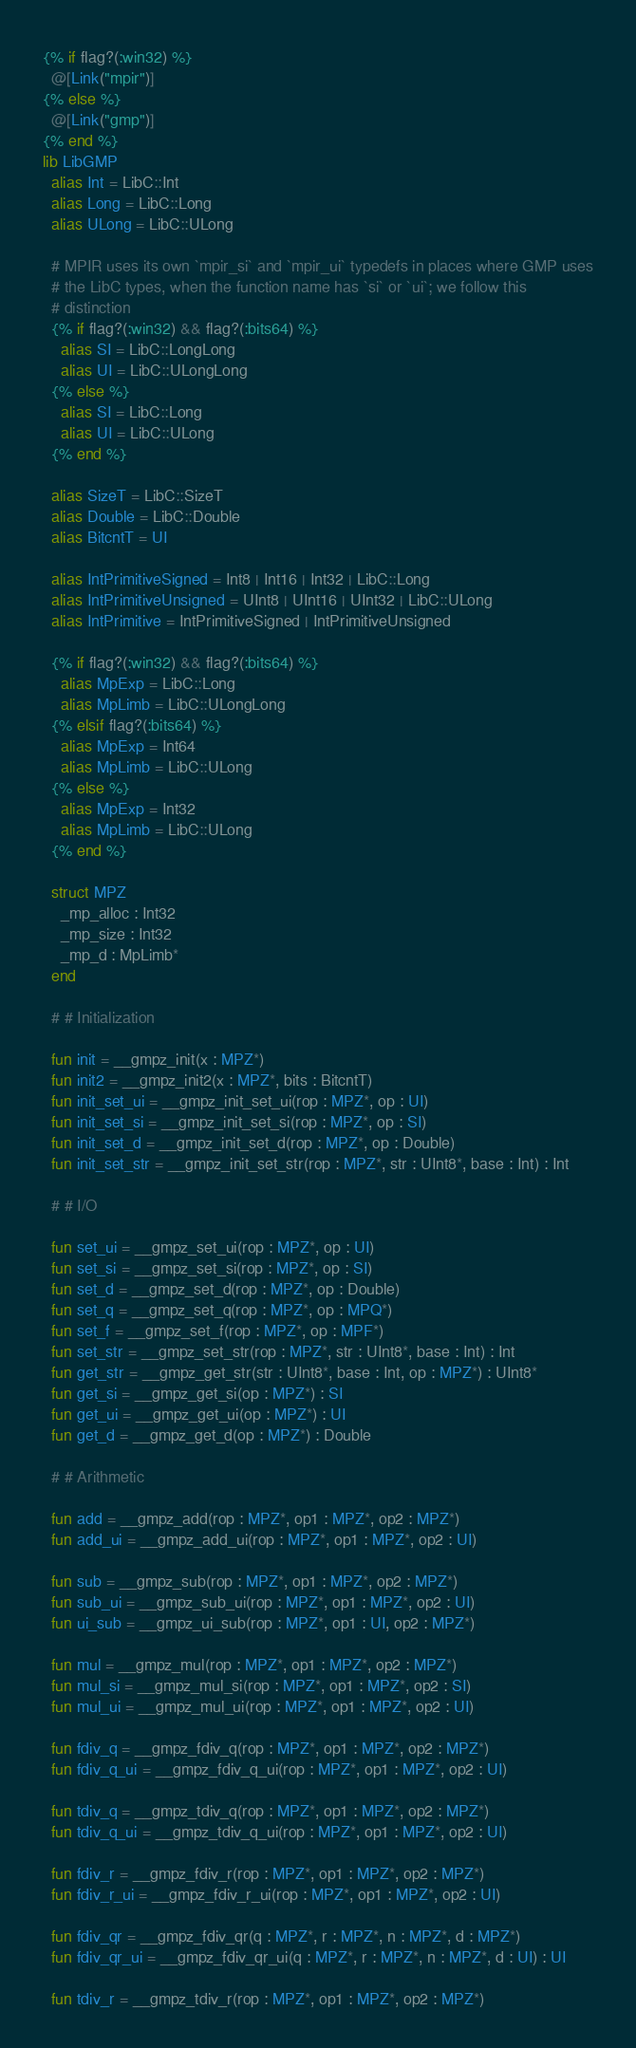<code> <loc_0><loc_0><loc_500><loc_500><_Crystal_>{% if flag?(:win32) %}
  @[Link("mpir")]
{% else %}
  @[Link("gmp")]
{% end %}
lib LibGMP
  alias Int = LibC::Int
  alias Long = LibC::Long
  alias ULong = LibC::ULong

  # MPIR uses its own `mpir_si` and `mpir_ui` typedefs in places where GMP uses
  # the LibC types, when the function name has `si` or `ui`; we follow this
  # distinction
  {% if flag?(:win32) && flag?(:bits64) %}
    alias SI = LibC::LongLong
    alias UI = LibC::ULongLong
  {% else %}
    alias SI = LibC::Long
    alias UI = LibC::ULong
  {% end %}

  alias SizeT = LibC::SizeT
  alias Double = LibC::Double
  alias BitcntT = UI

  alias IntPrimitiveSigned = Int8 | Int16 | Int32 | LibC::Long
  alias IntPrimitiveUnsigned = UInt8 | UInt16 | UInt32 | LibC::ULong
  alias IntPrimitive = IntPrimitiveSigned | IntPrimitiveUnsigned

  {% if flag?(:win32) && flag?(:bits64) %}
    alias MpExp = LibC::Long
    alias MpLimb = LibC::ULongLong
  {% elsif flag?(:bits64) %}
    alias MpExp = Int64
    alias MpLimb = LibC::ULong
  {% else %}
    alias MpExp = Int32
    alias MpLimb = LibC::ULong
  {% end %}

  struct MPZ
    _mp_alloc : Int32
    _mp_size : Int32
    _mp_d : MpLimb*
  end

  # # Initialization

  fun init = __gmpz_init(x : MPZ*)
  fun init2 = __gmpz_init2(x : MPZ*, bits : BitcntT)
  fun init_set_ui = __gmpz_init_set_ui(rop : MPZ*, op : UI)
  fun init_set_si = __gmpz_init_set_si(rop : MPZ*, op : SI)
  fun init_set_d = __gmpz_init_set_d(rop : MPZ*, op : Double)
  fun init_set_str = __gmpz_init_set_str(rop : MPZ*, str : UInt8*, base : Int) : Int

  # # I/O

  fun set_ui = __gmpz_set_ui(rop : MPZ*, op : UI)
  fun set_si = __gmpz_set_si(rop : MPZ*, op : SI)
  fun set_d = __gmpz_set_d(rop : MPZ*, op : Double)
  fun set_q = __gmpz_set_q(rop : MPZ*, op : MPQ*)
  fun set_f = __gmpz_set_f(rop : MPZ*, op : MPF*)
  fun set_str = __gmpz_set_str(rop : MPZ*, str : UInt8*, base : Int) : Int
  fun get_str = __gmpz_get_str(str : UInt8*, base : Int, op : MPZ*) : UInt8*
  fun get_si = __gmpz_get_si(op : MPZ*) : SI
  fun get_ui = __gmpz_get_ui(op : MPZ*) : UI
  fun get_d = __gmpz_get_d(op : MPZ*) : Double

  # # Arithmetic

  fun add = __gmpz_add(rop : MPZ*, op1 : MPZ*, op2 : MPZ*)
  fun add_ui = __gmpz_add_ui(rop : MPZ*, op1 : MPZ*, op2 : UI)

  fun sub = __gmpz_sub(rop : MPZ*, op1 : MPZ*, op2 : MPZ*)
  fun sub_ui = __gmpz_sub_ui(rop : MPZ*, op1 : MPZ*, op2 : UI)
  fun ui_sub = __gmpz_ui_sub(rop : MPZ*, op1 : UI, op2 : MPZ*)

  fun mul = __gmpz_mul(rop : MPZ*, op1 : MPZ*, op2 : MPZ*)
  fun mul_si = __gmpz_mul_si(rop : MPZ*, op1 : MPZ*, op2 : SI)
  fun mul_ui = __gmpz_mul_ui(rop : MPZ*, op1 : MPZ*, op2 : UI)

  fun fdiv_q = __gmpz_fdiv_q(rop : MPZ*, op1 : MPZ*, op2 : MPZ*)
  fun fdiv_q_ui = __gmpz_fdiv_q_ui(rop : MPZ*, op1 : MPZ*, op2 : UI)

  fun tdiv_q = __gmpz_tdiv_q(rop : MPZ*, op1 : MPZ*, op2 : MPZ*)
  fun tdiv_q_ui = __gmpz_tdiv_q_ui(rop : MPZ*, op1 : MPZ*, op2 : UI)

  fun fdiv_r = __gmpz_fdiv_r(rop : MPZ*, op1 : MPZ*, op2 : MPZ*)
  fun fdiv_r_ui = __gmpz_fdiv_r_ui(rop : MPZ*, op1 : MPZ*, op2 : UI)

  fun fdiv_qr = __gmpz_fdiv_qr(q : MPZ*, r : MPZ*, n : MPZ*, d : MPZ*)
  fun fdiv_qr_ui = __gmpz_fdiv_qr_ui(q : MPZ*, r : MPZ*, n : MPZ*, d : UI) : UI

  fun tdiv_r = __gmpz_tdiv_r(rop : MPZ*, op1 : MPZ*, op2 : MPZ*)</code> 